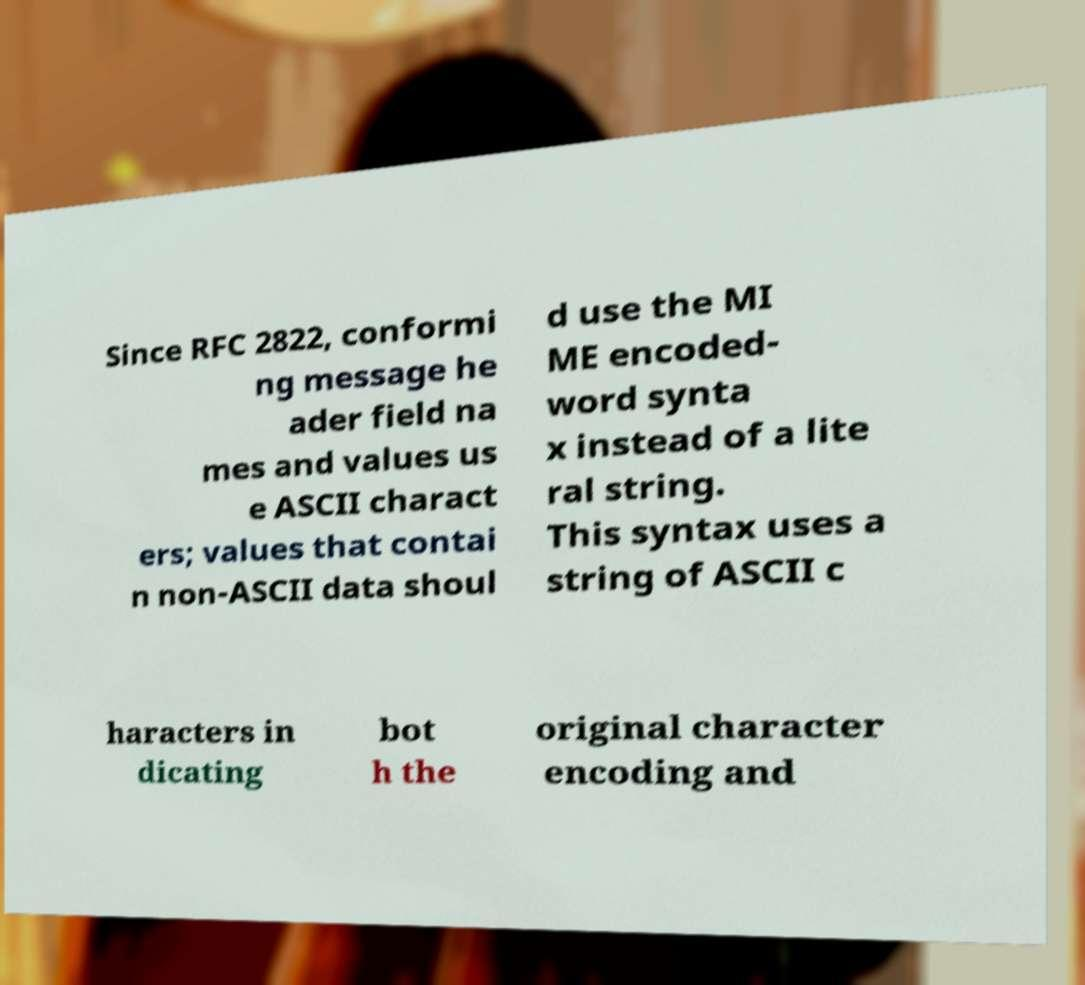Can you accurately transcribe the text from the provided image for me? Since RFC 2822, conformi ng message he ader field na mes and values us e ASCII charact ers; values that contai n non-ASCII data shoul d use the MI ME encoded- word synta x instead of a lite ral string. This syntax uses a string of ASCII c haracters in dicating bot h the original character encoding and 